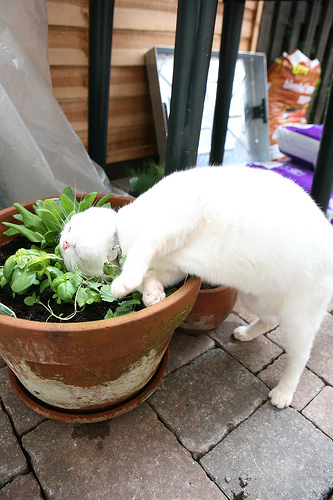Are there either orange umbrellas or bags? Yes, there are either orange umbrellas or bags present. 